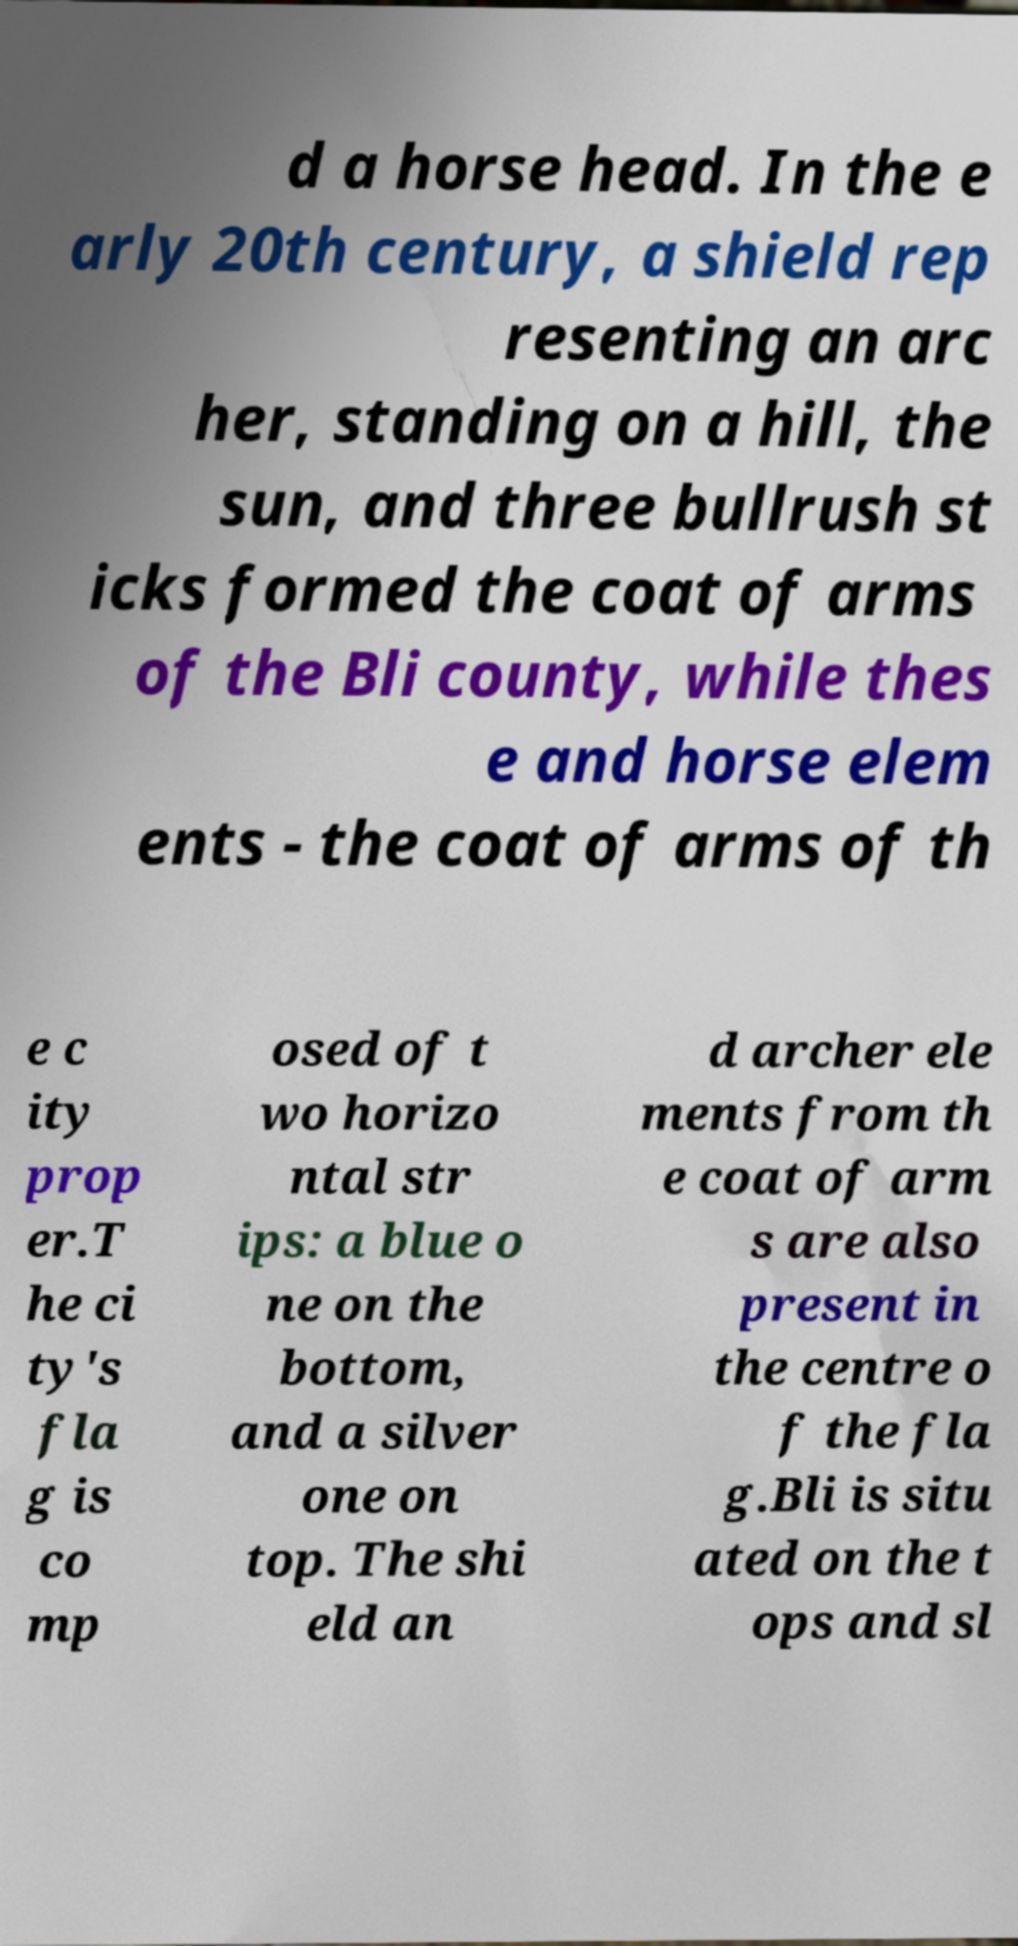For documentation purposes, I need the text within this image transcribed. Could you provide that? d a horse head. In the e arly 20th century, a shield rep resenting an arc her, standing on a hill, the sun, and three bullrush st icks formed the coat of arms of the Bli county, while thes e and horse elem ents - the coat of arms of th e c ity prop er.T he ci ty's fla g is co mp osed of t wo horizo ntal str ips: a blue o ne on the bottom, and a silver one on top. The shi eld an d archer ele ments from th e coat of arm s are also present in the centre o f the fla g.Bli is situ ated on the t ops and sl 